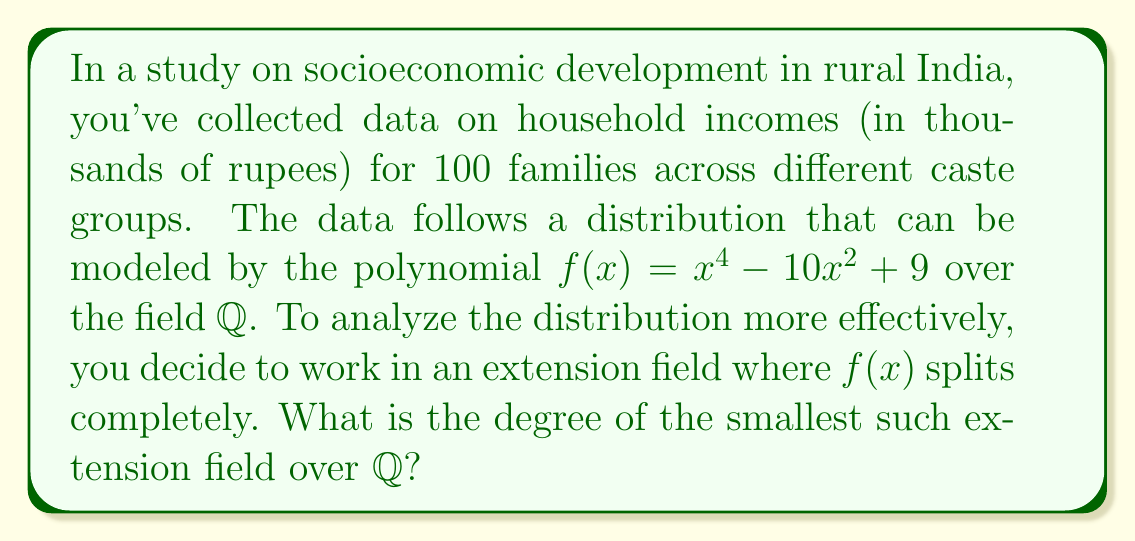Help me with this question. To find the degree of the smallest extension field where $f(x)$ splits completely, we need to follow these steps:

1) First, let's factor $f(x) = x^4 - 10x^2 + 9$:
   
   $f(x) = (x^2 - 9)(x^2 - 1) = (x+3)(x-3)(x+1)(x-1)$

2) The roots of $f(x)$ are $\{-3, 3, -1, 1\}$

3) All these roots are rational numbers, which means they are already in $\mathbb{Q}$

4) Since all roots are in $\mathbb{Q}$, the polynomial splits completely over $\mathbb{Q}$

5) Therefore, we don't need to create an extension field. The smallest field where $f(x)$ splits completely is $\mathbb{Q}$ itself

6) The degree of $\mathbb{Q}$ over $\mathbb{Q}$ is 1

Thus, the degree of the smallest extension field where $f(x)$ splits completely is 1.
Answer: 1 